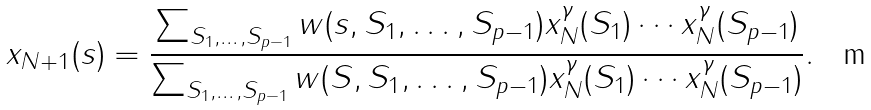Convert formula to latex. <formula><loc_0><loc_0><loc_500><loc_500>x _ { N + 1 } ( s ) = \frac { \sum _ { S _ { 1 } , \dots , S _ { p - 1 } } w ( s , S _ { 1 } , \dots , S _ { p - 1 } ) x _ { N } ^ { \gamma } ( S _ { 1 } ) \cdots x _ { N } ^ { \gamma } ( S _ { p - 1 } ) } { \sum _ { S _ { 1 } , \dots , S _ { p - 1 } } w ( S , S _ { 1 } , \dots , S _ { p - 1 } ) x _ { N } ^ { \gamma } ( S _ { 1 } ) \cdots x _ { N } ^ { \gamma } ( S _ { p - 1 } ) } .</formula> 